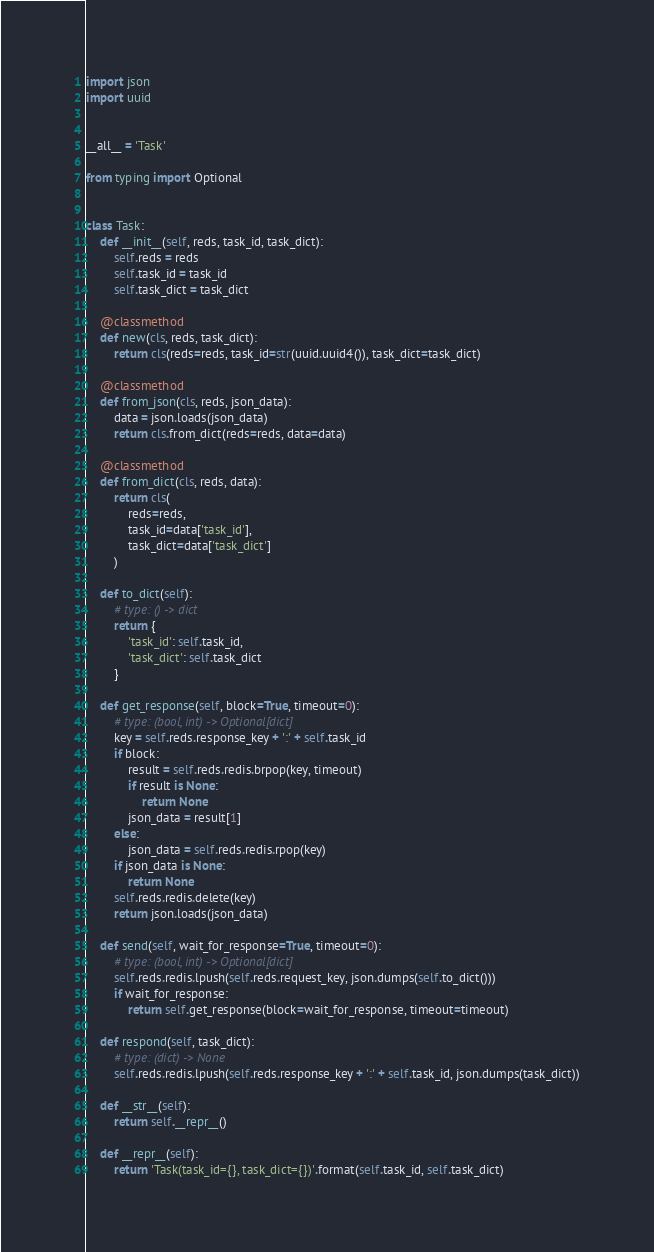Convert code to text. <code><loc_0><loc_0><loc_500><loc_500><_Python_>import json
import uuid


__all__ = 'Task'

from typing import Optional


class Task:
    def __init__(self, reds, task_id, task_dict):
        self.reds = reds
        self.task_id = task_id
        self.task_dict = task_dict

    @classmethod
    def new(cls, reds, task_dict):
        return cls(reds=reds, task_id=str(uuid.uuid4()), task_dict=task_dict)

    @classmethod
    def from_json(cls, reds, json_data):
        data = json.loads(json_data)
        return cls.from_dict(reds=reds, data=data)

    @classmethod
    def from_dict(cls, reds, data):
        return cls(
            reds=reds,
            task_id=data['task_id'],
            task_dict=data['task_dict']
        )

    def to_dict(self):
        # type: () -> dict
        return {
            'task_id': self.task_id,
            'task_dict': self.task_dict
        }

    def get_response(self, block=True, timeout=0):
        # type: (bool, int) -> Optional[dict]
        key = self.reds.response_key + ':' + self.task_id
        if block:
            result = self.reds.redis.brpop(key, timeout)
            if result is None:
                return None
            json_data = result[1]
        else:
            json_data = self.reds.redis.rpop(key)
        if json_data is None:
            return None
        self.reds.redis.delete(key)
        return json.loads(json_data)

    def send(self, wait_for_response=True, timeout=0):
        # type: (bool, int) -> Optional[dict]
        self.reds.redis.lpush(self.reds.request_key, json.dumps(self.to_dict()))
        if wait_for_response:
            return self.get_response(block=wait_for_response, timeout=timeout)

    def respond(self, task_dict):
        # type: (dict) -> None
        self.reds.redis.lpush(self.reds.response_key + ':' + self.task_id, json.dumps(task_dict))

    def __str__(self):
        return self.__repr__()

    def __repr__(self):
        return 'Task(task_id={}, task_dict={})'.format(self.task_id, self.task_dict)
</code> 